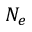<formula> <loc_0><loc_0><loc_500><loc_500>N _ { e }</formula> 